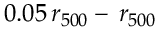Convert formula to latex. <formula><loc_0><loc_0><loc_500><loc_500>0 . 0 5 \, r _ { 5 0 0 } - \, r _ { 5 0 0 }</formula> 